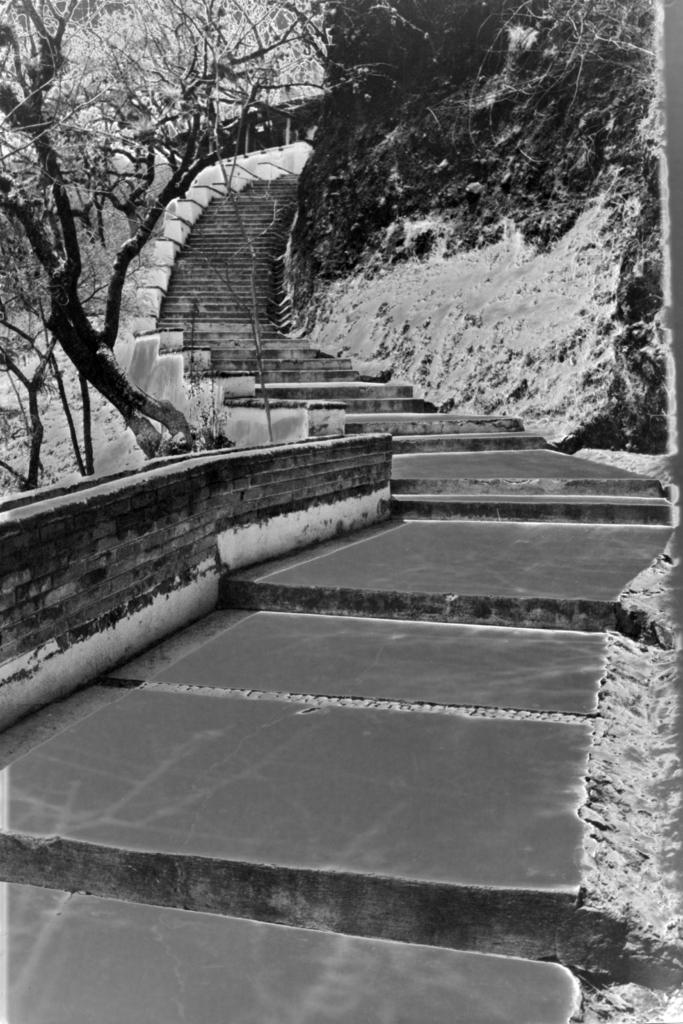What type of structure is present in the image? There is a staircase in the image. What natural features can be seen in the background? Mountains are visible in the image. What type of vegetation is present in the image? There is a group of trees in the image. What type of crate is being used to cover the trees in the image? There is no crate present in the image, nor are the trees being covered by any object. 